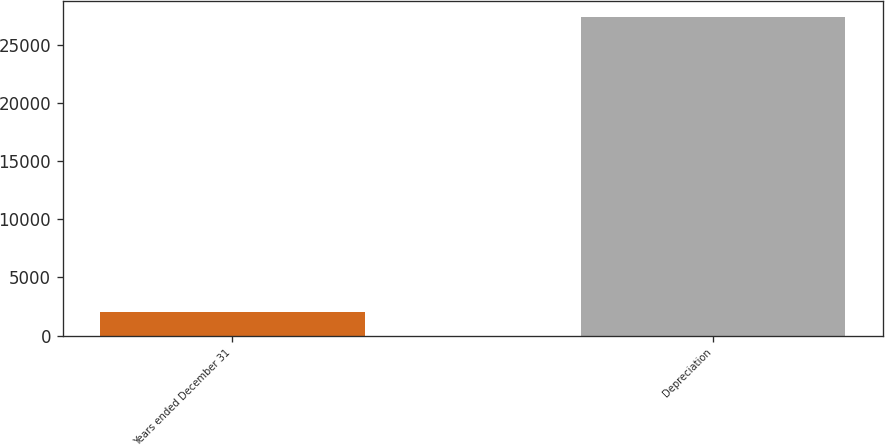<chart> <loc_0><loc_0><loc_500><loc_500><bar_chart><fcel>Years ended December 31<fcel>Depreciation<nl><fcel>2017<fcel>27381<nl></chart> 